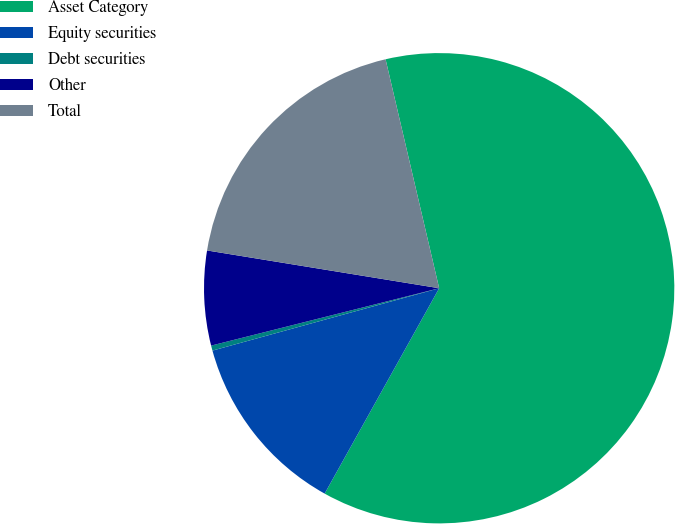<chart> <loc_0><loc_0><loc_500><loc_500><pie_chart><fcel>Asset Category<fcel>Equity securities<fcel>Debt securities<fcel>Other<fcel>Total<nl><fcel>61.75%<fcel>12.63%<fcel>0.35%<fcel>6.49%<fcel>18.77%<nl></chart> 